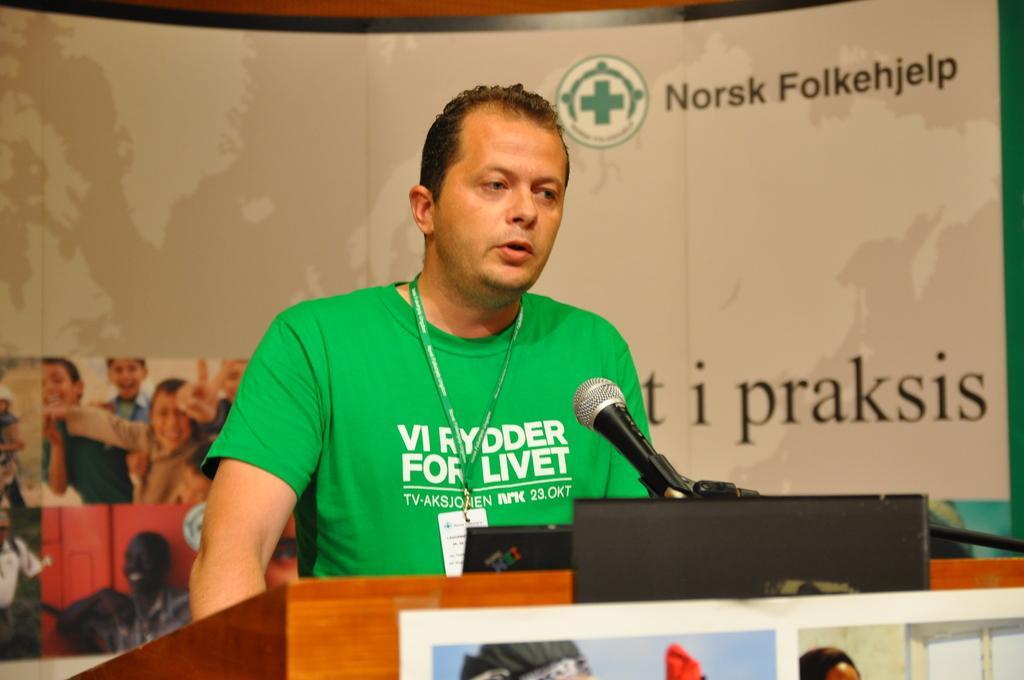Describe this image in one or two sentences. In the middle of the image we can see a man, in front of him we can find a microphone and a podium, in the background we can see a hoarding. 